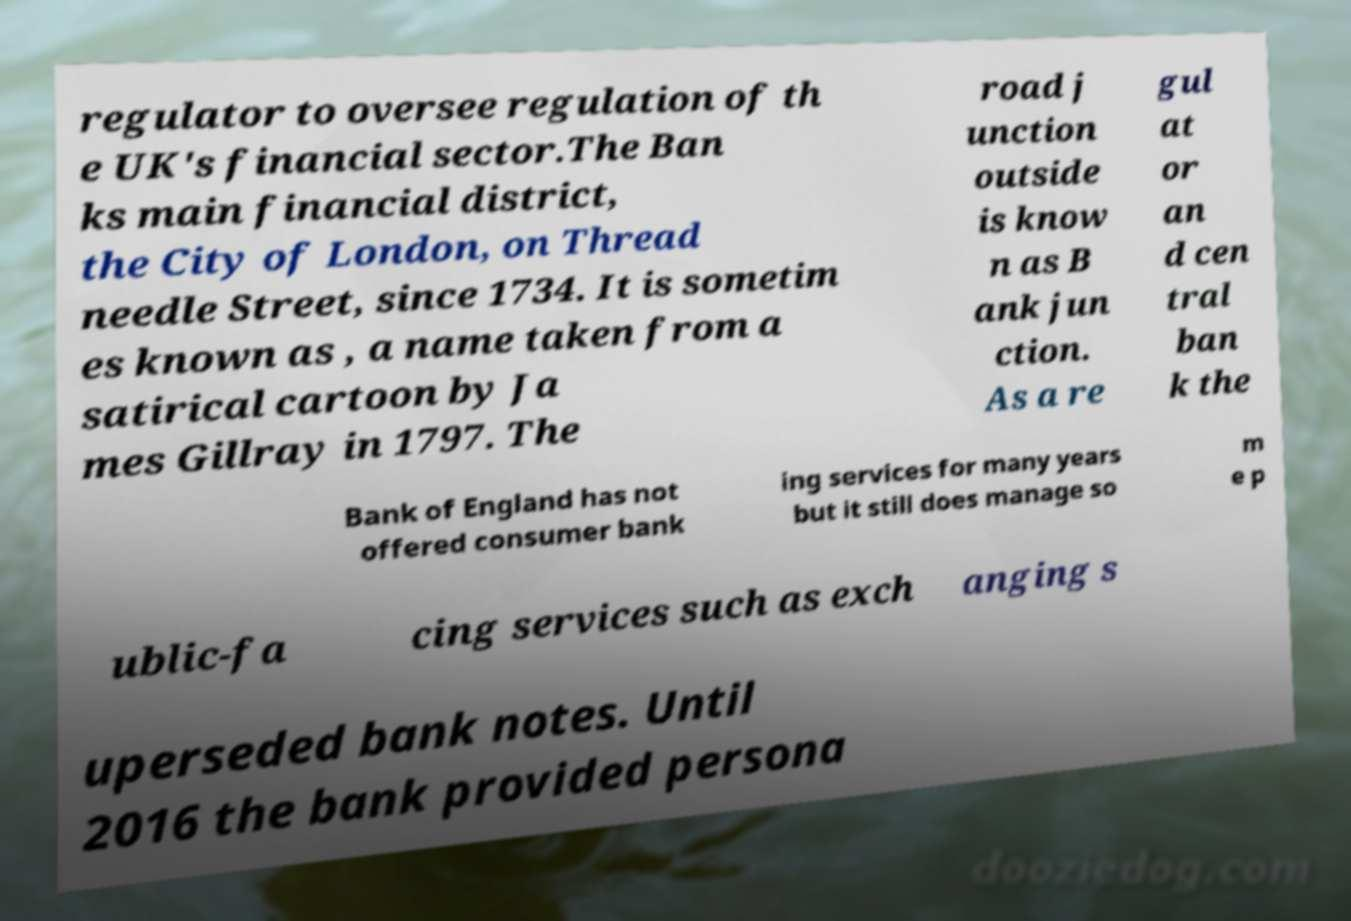Please identify and transcribe the text found in this image. regulator to oversee regulation of th e UK's financial sector.The Ban ks main financial district, the City of London, on Thread needle Street, since 1734. It is sometim es known as , a name taken from a satirical cartoon by Ja mes Gillray in 1797. The road j unction outside is know n as B ank jun ction. As a re gul at or an d cen tral ban k the Bank of England has not offered consumer bank ing services for many years but it still does manage so m e p ublic-fa cing services such as exch anging s uperseded bank notes. Until 2016 the bank provided persona 